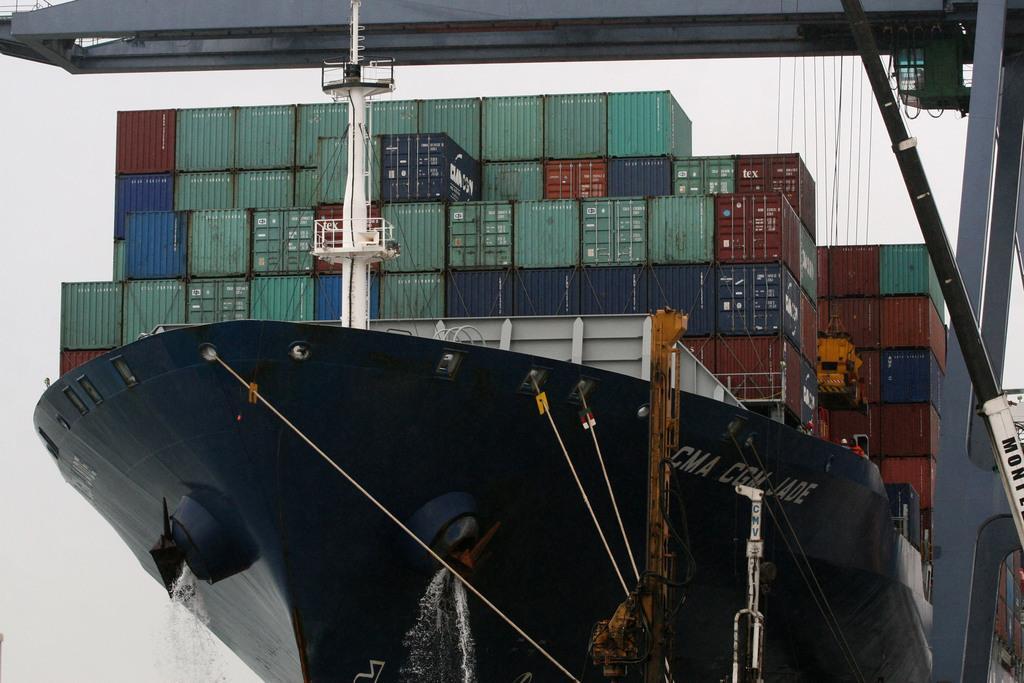How would you summarize this image in a sentence or two? In this picture, we see a black color ship. This ship contains many containers which are in green, blue, brown and grey color. In the background, we see the sky. 